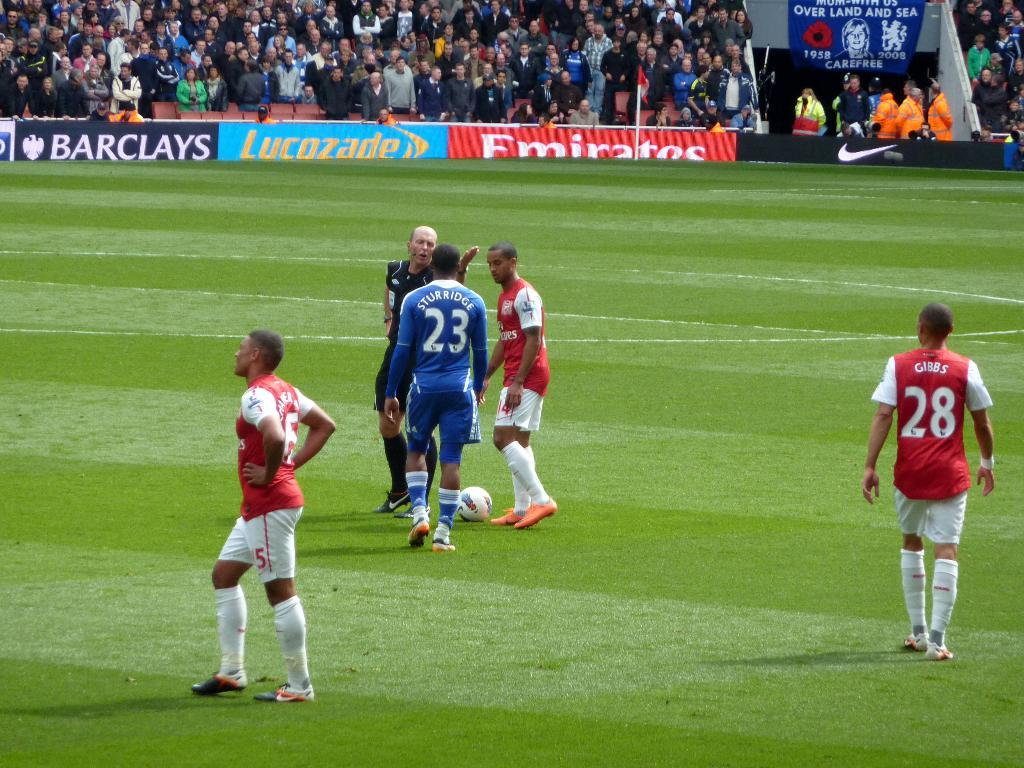<image>
Relay a brief, clear account of the picture shown. A soccer player with a blue uniform and the number 23 on his back is speaking to a referee. 